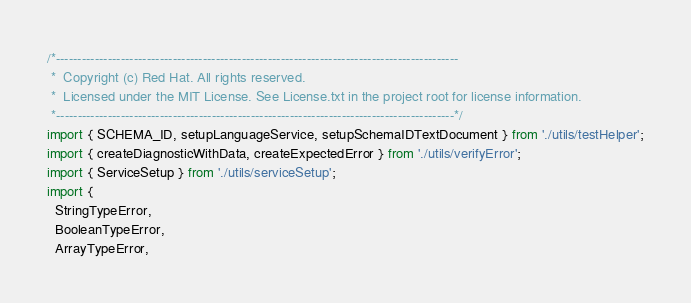Convert code to text. <code><loc_0><loc_0><loc_500><loc_500><_TypeScript_>/*---------------------------------------------------------------------------------------------
 *  Copyright (c) Red Hat. All rights reserved.
 *  Licensed under the MIT License. See License.txt in the project root for license information.
 *--------------------------------------------------------------------------------------------*/
import { SCHEMA_ID, setupLanguageService, setupSchemaIDTextDocument } from './utils/testHelper';
import { createDiagnosticWithData, createExpectedError } from './utils/verifyError';
import { ServiceSetup } from './utils/serviceSetup';
import {
  StringTypeError,
  BooleanTypeError,
  ArrayTypeError,</code> 